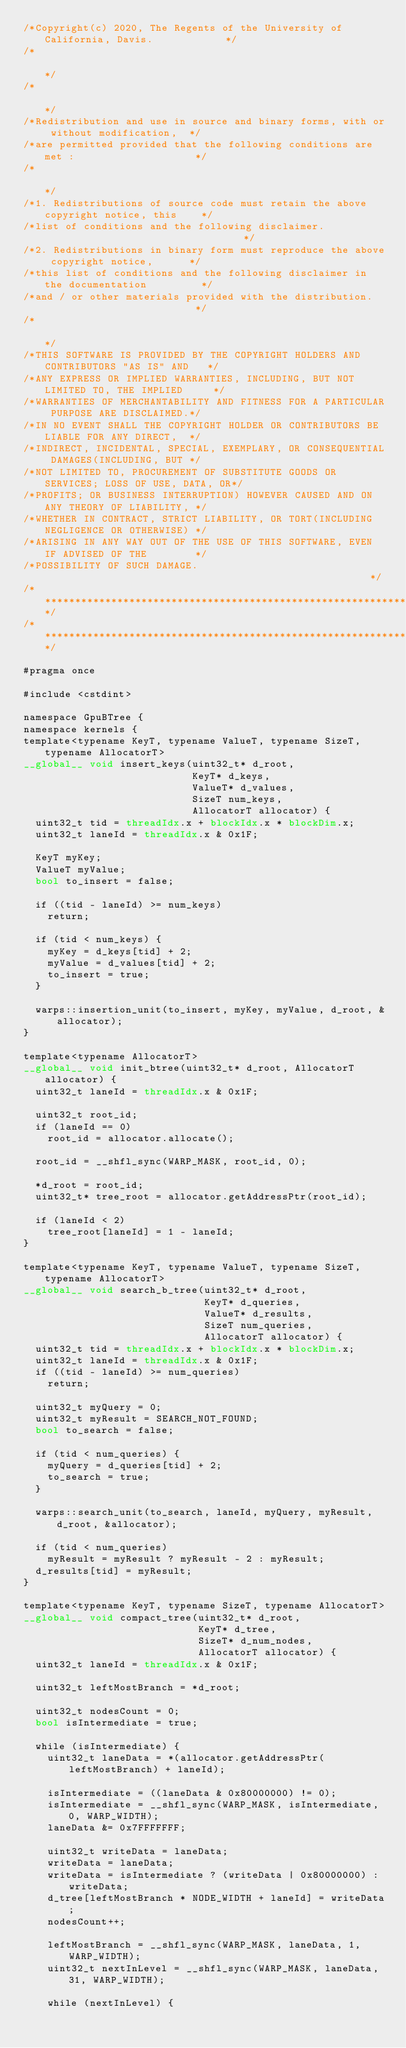Convert code to text. <code><loc_0><loc_0><loc_500><loc_500><_Cuda_>/*Copyright(c) 2020, The Regents of the University of California, Davis.            */
/*                                                                                  */
/*                                                                                  */
/*Redistribution and use in source and binary forms, with or without modification,  */
/*are permitted provided that the following conditions are met :                    */
/*                                                                                  */
/*1. Redistributions of source code must retain the above copyright notice, this    */
/*list of conditions and the following disclaimer.                                  */
/*2. Redistributions in binary form must reproduce the above copyright notice,      */
/*this list of conditions and the following disclaimer in the documentation         */
/*and / or other materials provided with the distribution.                          */
/*                                                                                  */
/*THIS SOFTWARE IS PROVIDED BY THE COPYRIGHT HOLDERS AND CONTRIBUTORS "AS IS" AND   */
/*ANY EXPRESS OR IMPLIED WARRANTIES, INCLUDING, BUT NOT LIMITED TO, THE IMPLIED     */
/*WARRANTIES OF MERCHANTABILITY AND FITNESS FOR A PARTICULAR PURPOSE ARE DISCLAIMED.*/
/*IN NO EVENT SHALL THE COPYRIGHT HOLDER OR CONTRIBUTORS BE LIABLE FOR ANY DIRECT,  */
/*INDIRECT, INCIDENTAL, SPECIAL, EXEMPLARY, OR CONSEQUENTIAL DAMAGES(INCLUDING, BUT */
/*NOT LIMITED TO, PROCUREMENT OF SUBSTITUTE GOODS OR SERVICES; LOSS OF USE, DATA, OR*/
/*PROFITS; OR BUSINESS INTERRUPTION) HOWEVER CAUSED AND ON ANY THEORY OF LIABILITY, */
/*WHETHER IN CONTRACT, STRICT LIABILITY, OR TORT(INCLUDING NEGLIGENCE OR OTHERWISE) */
/*ARISING IN ANY WAY OUT OF THE USE OF THIS SOFTWARE, EVEN IF ADVISED OF THE        */
/*POSSIBILITY OF SUCH DAMAGE.                                                       */
/************************************************************************************/
/************************************************************************************/

#pragma once

#include <cstdint>

namespace GpuBTree {
namespace kernels {
template<typename KeyT, typename ValueT, typename SizeT, typename AllocatorT>
__global__ void insert_keys(uint32_t* d_root,
                            KeyT* d_keys,
                            ValueT* d_values,
                            SizeT num_keys,
                            AllocatorT allocator) {
  uint32_t tid = threadIdx.x + blockIdx.x * blockDim.x;
  uint32_t laneId = threadIdx.x & 0x1F;

  KeyT myKey;
  ValueT myValue;
  bool to_insert = false;

  if ((tid - laneId) >= num_keys)
    return;

  if (tid < num_keys) {
    myKey = d_keys[tid] + 2;
    myValue = d_values[tid] + 2;
    to_insert = true;
  }

  warps::insertion_unit(to_insert, myKey, myValue, d_root, &allocator);
}

template<typename AllocatorT>
__global__ void init_btree(uint32_t* d_root, AllocatorT allocator) {
  uint32_t laneId = threadIdx.x & 0x1F;

  uint32_t root_id;
  if (laneId == 0)
    root_id = allocator.allocate();

  root_id = __shfl_sync(WARP_MASK, root_id, 0);

  *d_root = root_id;
  uint32_t* tree_root = allocator.getAddressPtr(root_id);

  if (laneId < 2)
    tree_root[laneId] = 1 - laneId;
}

template<typename KeyT, typename ValueT, typename SizeT, typename AllocatorT>
__global__ void search_b_tree(uint32_t* d_root,
                              KeyT* d_queries,
                              ValueT* d_results,
                              SizeT num_queries,
                              AllocatorT allocator) {
  uint32_t tid = threadIdx.x + blockIdx.x * blockDim.x;
  uint32_t laneId = threadIdx.x & 0x1F;
  if ((tid - laneId) >= num_queries)
    return;

  uint32_t myQuery = 0;
  uint32_t myResult = SEARCH_NOT_FOUND;
  bool to_search = false;

  if (tid < num_queries) {
    myQuery = d_queries[tid] + 2;
    to_search = true;
  }

  warps::search_unit(to_search, laneId, myQuery, myResult, d_root, &allocator);

  if (tid < num_queries)
    myResult = myResult ? myResult - 2 : myResult;
  d_results[tid] = myResult;
}

template<typename KeyT, typename SizeT, typename AllocatorT>
__global__ void compact_tree(uint32_t* d_root,
                             KeyT* d_tree,
                             SizeT* d_num_nodes,
                             AllocatorT allocator) {
  uint32_t laneId = threadIdx.x & 0x1F;

  uint32_t leftMostBranch = *d_root;

  uint32_t nodesCount = 0;
  bool isIntermediate = true;

  while (isIntermediate) {
    uint32_t laneData = *(allocator.getAddressPtr(leftMostBranch) + laneId);

    isIntermediate = ((laneData & 0x80000000) != 0);
    isIntermediate = __shfl_sync(WARP_MASK, isIntermediate, 0, WARP_WIDTH);
    laneData &= 0x7FFFFFFF;

    uint32_t writeData = laneData;
    writeData = laneData;
    writeData = isIntermediate ? (writeData | 0x80000000) : writeData;
    d_tree[leftMostBranch * NODE_WIDTH + laneId] = writeData;
    nodesCount++;

    leftMostBranch = __shfl_sync(WARP_MASK, laneData, 1, WARP_WIDTH);
    uint32_t nextInLevel = __shfl_sync(WARP_MASK, laneData, 31, WARP_WIDTH);

    while (nextInLevel) {</code> 